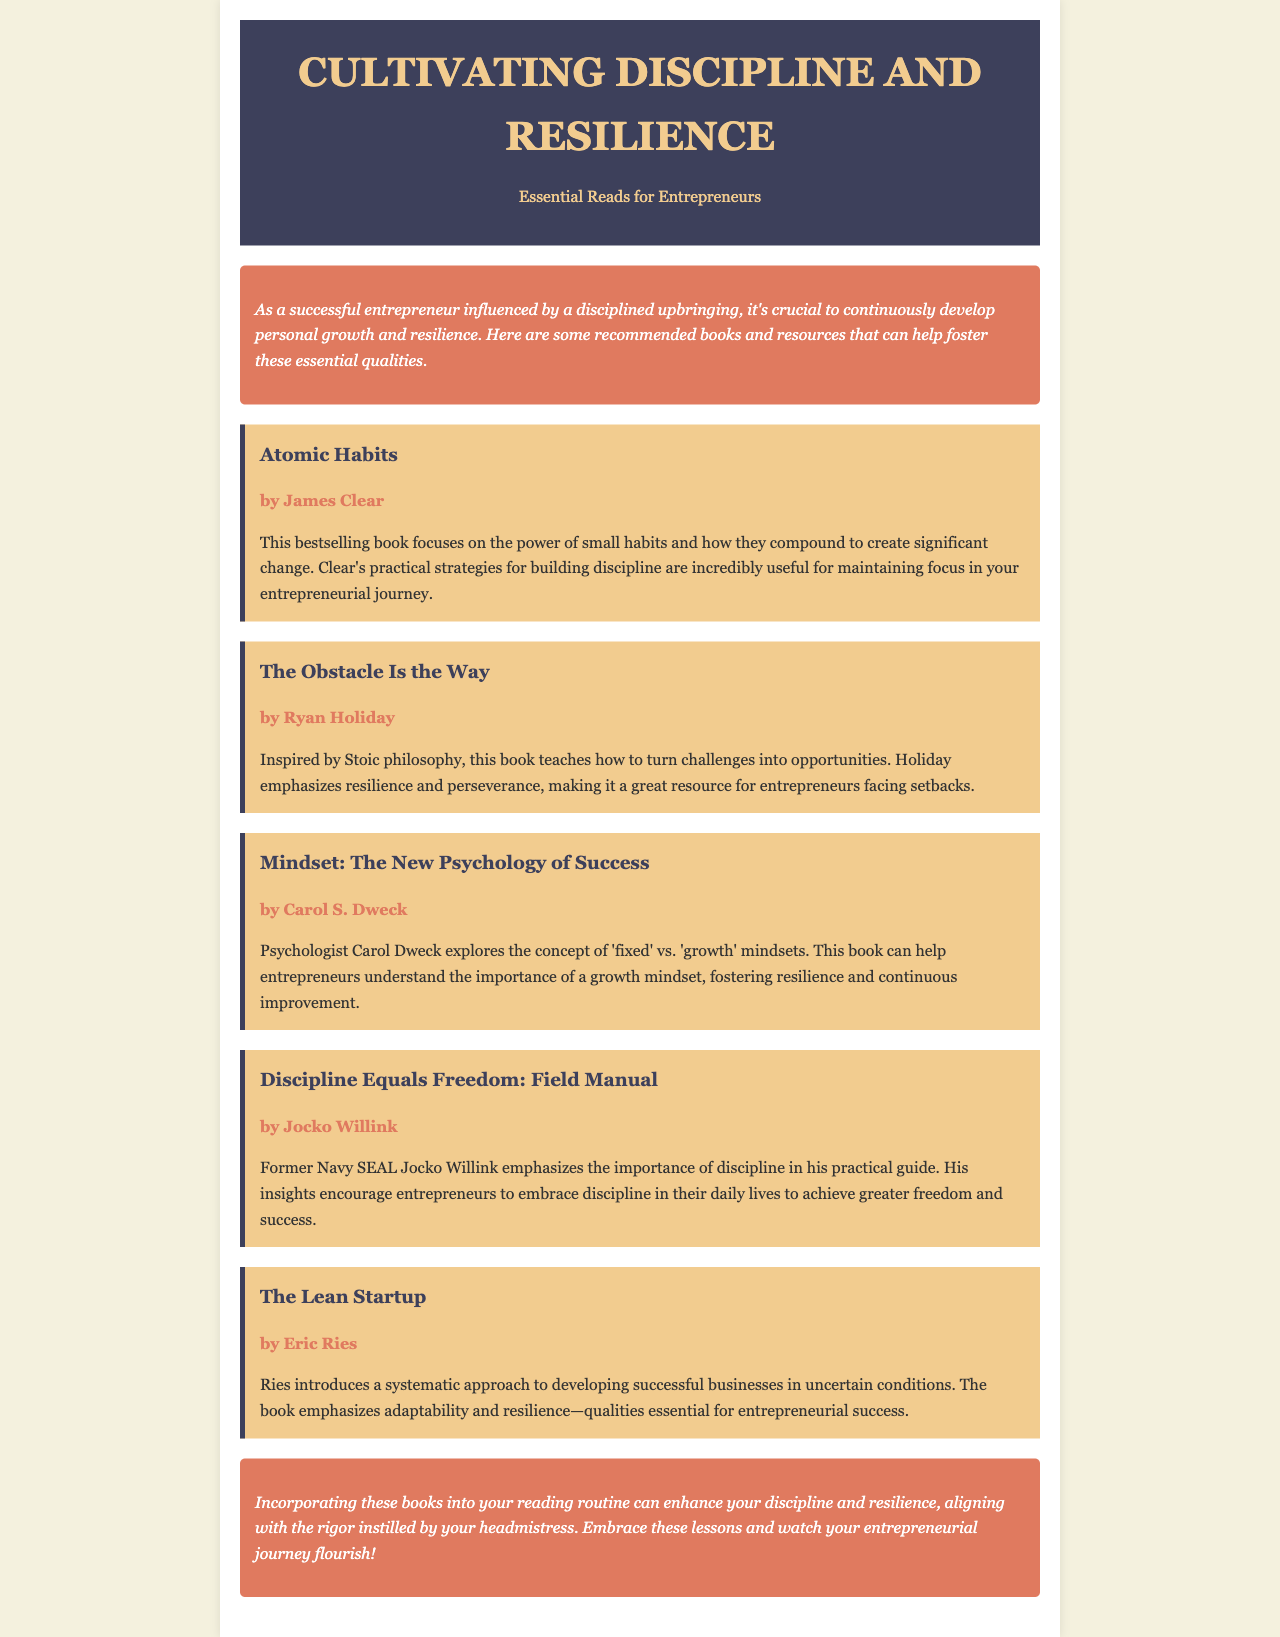What is the title of the newsletter? The title is prominently stated at the top of the document, focusing on discipline and resilience for entrepreneurs.
Answer: Cultivating Discipline and Resilience Who is the author of "Atomic Habits"? The author's name is mentioned directly below the book title in the listed resources.
Answer: James Clear How many books are recommended in the newsletter? The total number of resources is tallied from the document where each book is listed separately.
Answer: Five What philosophy does "The Obstacle Is the Way" draw from? The document specifies that this book is inspired by a particular philosophical approach.
Answer: Stoic philosophy Which book emphasizes the concept of 'growth' vs. 'fixed' mindsets? The document directly links this concept to a specific author's work and book title in the resources.
Answer: Mindset: The New Psychology of Success What is the main focus of "Discipline Equals Freedom: Field Manual"? The document summarizes the primary emphasis of this book as written by its author.
Answer: Importance of discipline Which book is suggested for developing businesses in uncertain conditions? This book is explicitly highlighted in the document as a resource for entrepreneurs dealing with ambiguity in business.
Answer: The Lean Startup What is the conclusion's main message regarding the books? The conclusion encapsulates the overall sentiment of incorporating the recommended books into personal routines.
Answer: Enhance discipline and resilience 